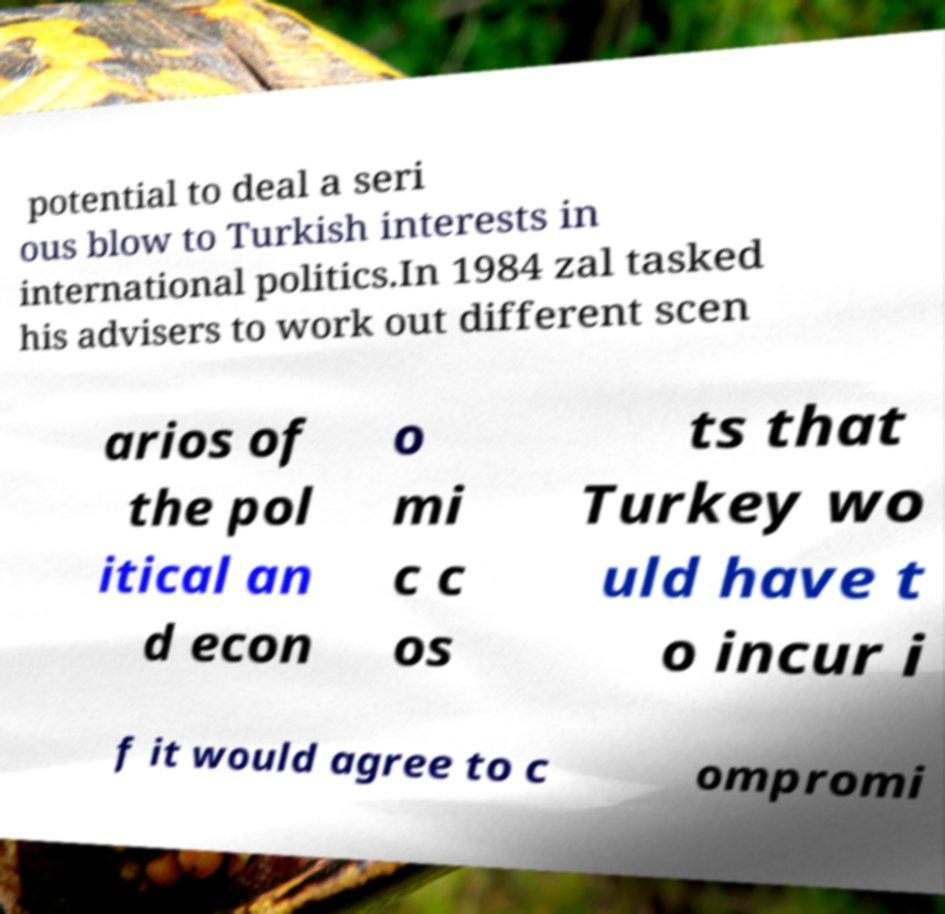What messages or text are displayed in this image? I need them in a readable, typed format. potential to deal a seri ous blow to Turkish interests in international politics.In 1984 zal tasked his advisers to work out different scen arios of the pol itical an d econ o mi c c os ts that Turkey wo uld have t o incur i f it would agree to c ompromi 